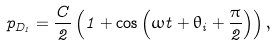<formula> <loc_0><loc_0><loc_500><loc_500>p _ { D _ { 1 } } = \frac { C } { 2 } \left ( 1 + \cos \left ( \omega t + \theta _ { i } + \frac { \pi } { 2 } \right ) \right ) ,</formula> 